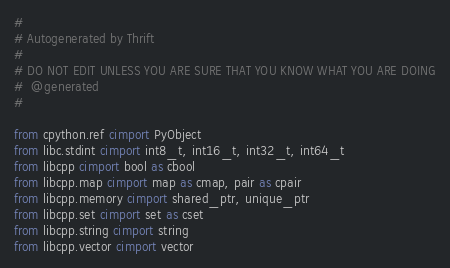Convert code to text. <code><loc_0><loc_0><loc_500><loc_500><_Cython_>#
# Autogenerated by Thrift
#
# DO NOT EDIT UNLESS YOU ARE SURE THAT YOU KNOW WHAT YOU ARE DOING
#  @generated
#

from cpython.ref cimport PyObject
from libc.stdint cimport int8_t, int16_t, int32_t, int64_t
from libcpp cimport bool as cbool
from libcpp.map cimport map as cmap, pair as cpair
from libcpp.memory cimport shared_ptr, unique_ptr
from libcpp.set cimport set as cset
from libcpp.string cimport string
from libcpp.vector cimport vector
</code> 